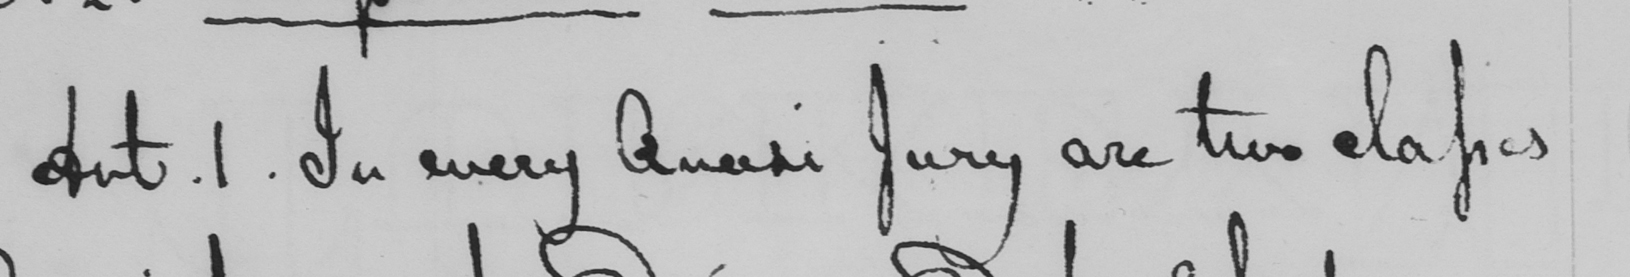Can you read and transcribe this handwriting? Art . 1 . In every Quasi Jury are two classes 